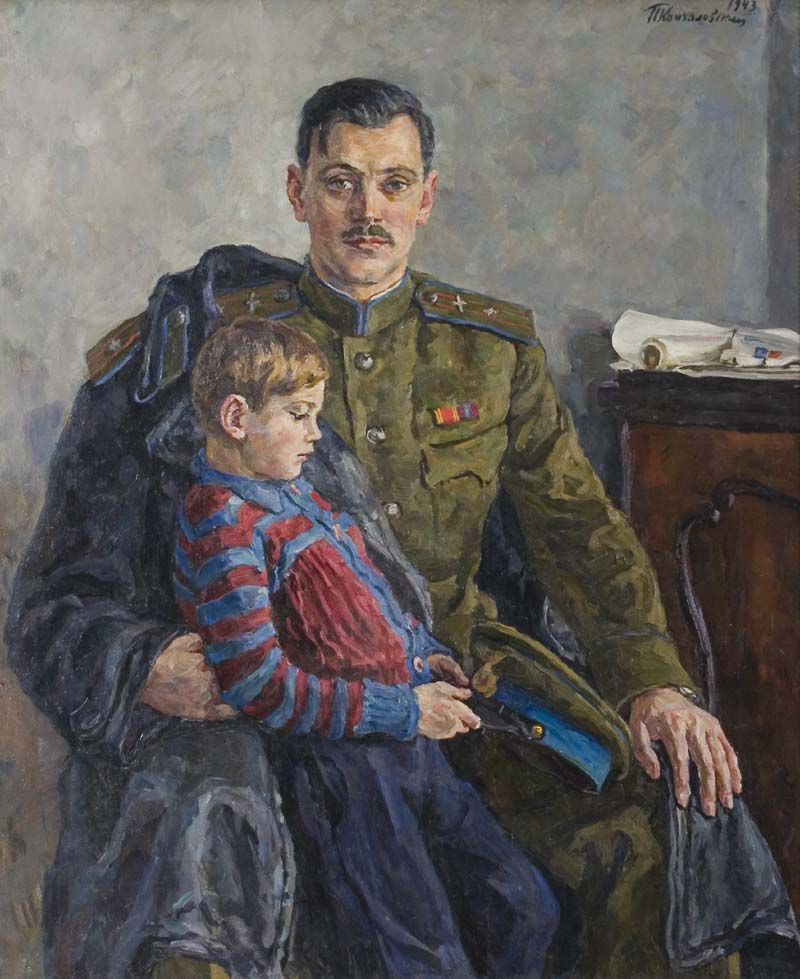What does the medal on the man’s chest signify? The medal pinned on the man’s chest likely signifies a commendation or recognition within the military. While the specific details or the type of medal are not clear from the image alone, such decorations are typically awarded for acts of bravery, long service, or distinguished conduct. In the context of this painting, it adds to the narrative of the man’s respectable military career and personal sacrifices. 